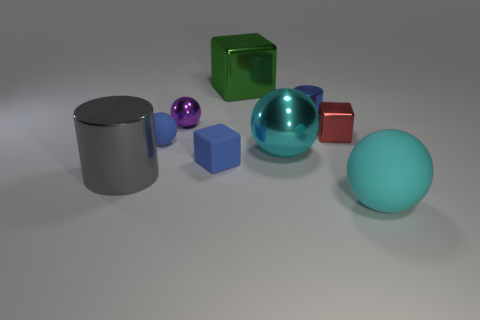Imagine this is a still from an animation, what could the storyline be? In the realm of imagination, we could perceive these objects as characters in a vibrant world of shapes. The storyline could revolve around the shiny spheres and cubes wanting to find their place on the surface, exploring themes of belonging and identity. As the narrative unfolds, the 'matte' characters might feel overshadowed by the 'glossy' ones, only to discover that each has a unique role and beauty, contributing to the harmony of their world. The 'translucent' sphere could act as the wise figure that helps bridge differences, leading to a heartwarming resolution of acceptance and unity. 